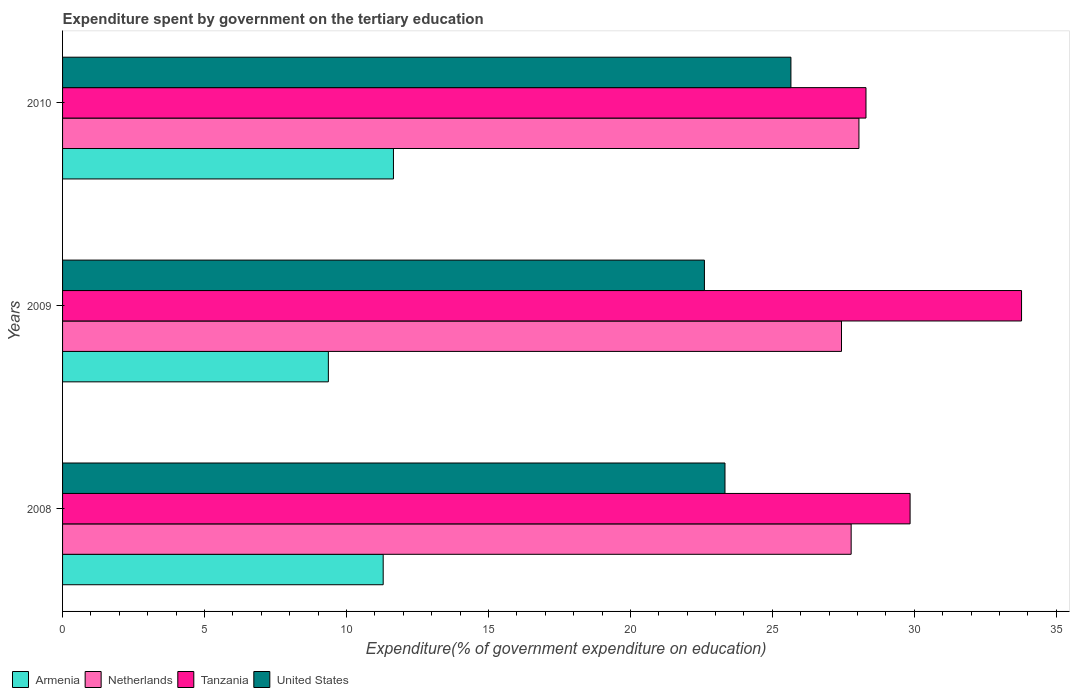How many different coloured bars are there?
Your answer should be compact. 4. How many groups of bars are there?
Your response must be concise. 3. Are the number of bars per tick equal to the number of legend labels?
Provide a succinct answer. Yes. Are the number of bars on each tick of the Y-axis equal?
Provide a succinct answer. Yes. How many bars are there on the 3rd tick from the top?
Your response must be concise. 4. What is the expenditure spent by government on the tertiary education in Netherlands in 2008?
Offer a very short reply. 27.77. Across all years, what is the maximum expenditure spent by government on the tertiary education in Armenia?
Make the answer very short. 11.65. Across all years, what is the minimum expenditure spent by government on the tertiary education in United States?
Provide a succinct answer. 22.61. In which year was the expenditure spent by government on the tertiary education in Netherlands maximum?
Offer a very short reply. 2010. What is the total expenditure spent by government on the tertiary education in Netherlands in the graph?
Ensure brevity in your answer.  83.26. What is the difference between the expenditure spent by government on the tertiary education in Armenia in 2008 and that in 2010?
Offer a terse response. -0.36. What is the difference between the expenditure spent by government on the tertiary education in Armenia in 2010 and the expenditure spent by government on the tertiary education in Tanzania in 2009?
Your response must be concise. -22.12. What is the average expenditure spent by government on the tertiary education in Tanzania per year?
Provide a succinct answer. 30.64. In the year 2009, what is the difference between the expenditure spent by government on the tertiary education in United States and expenditure spent by government on the tertiary education in Netherlands?
Your answer should be compact. -4.83. What is the ratio of the expenditure spent by government on the tertiary education in Netherlands in 2009 to that in 2010?
Give a very brief answer. 0.98. What is the difference between the highest and the second highest expenditure spent by government on the tertiary education in Netherlands?
Make the answer very short. 0.27. What is the difference between the highest and the lowest expenditure spent by government on the tertiary education in Tanzania?
Provide a short and direct response. 5.48. Is the sum of the expenditure spent by government on the tertiary education in United States in 2008 and 2010 greater than the maximum expenditure spent by government on the tertiary education in Armenia across all years?
Your answer should be very brief. Yes. Is it the case that in every year, the sum of the expenditure spent by government on the tertiary education in Tanzania and expenditure spent by government on the tertiary education in Netherlands is greater than the sum of expenditure spent by government on the tertiary education in Armenia and expenditure spent by government on the tertiary education in United States?
Your answer should be compact. Yes. What does the 2nd bar from the top in 2010 represents?
Ensure brevity in your answer.  Tanzania. What does the 3rd bar from the bottom in 2009 represents?
Your answer should be very brief. Tanzania. Is it the case that in every year, the sum of the expenditure spent by government on the tertiary education in Netherlands and expenditure spent by government on the tertiary education in Tanzania is greater than the expenditure spent by government on the tertiary education in United States?
Offer a very short reply. Yes. How many bars are there?
Make the answer very short. 12. Are the values on the major ticks of X-axis written in scientific E-notation?
Offer a terse response. No. Does the graph contain grids?
Make the answer very short. No. Where does the legend appear in the graph?
Offer a terse response. Bottom left. What is the title of the graph?
Provide a short and direct response. Expenditure spent by government on the tertiary education. What is the label or title of the X-axis?
Make the answer very short. Expenditure(% of government expenditure on education). What is the label or title of the Y-axis?
Offer a terse response. Years. What is the Expenditure(% of government expenditure on education) in Armenia in 2008?
Ensure brevity in your answer.  11.29. What is the Expenditure(% of government expenditure on education) in Netherlands in 2008?
Give a very brief answer. 27.77. What is the Expenditure(% of government expenditure on education) of Tanzania in 2008?
Keep it short and to the point. 29.85. What is the Expenditure(% of government expenditure on education) in United States in 2008?
Your answer should be compact. 23.33. What is the Expenditure(% of government expenditure on education) in Armenia in 2009?
Offer a terse response. 9.36. What is the Expenditure(% of government expenditure on education) of Netherlands in 2009?
Offer a terse response. 27.43. What is the Expenditure(% of government expenditure on education) of Tanzania in 2009?
Your answer should be very brief. 33.78. What is the Expenditure(% of government expenditure on education) of United States in 2009?
Your response must be concise. 22.61. What is the Expenditure(% of government expenditure on education) in Armenia in 2010?
Make the answer very short. 11.65. What is the Expenditure(% of government expenditure on education) in Netherlands in 2010?
Your response must be concise. 28.05. What is the Expenditure(% of government expenditure on education) of Tanzania in 2010?
Your answer should be compact. 28.3. What is the Expenditure(% of government expenditure on education) in United States in 2010?
Give a very brief answer. 25.65. Across all years, what is the maximum Expenditure(% of government expenditure on education) of Armenia?
Ensure brevity in your answer.  11.65. Across all years, what is the maximum Expenditure(% of government expenditure on education) in Netherlands?
Provide a succinct answer. 28.05. Across all years, what is the maximum Expenditure(% of government expenditure on education) in Tanzania?
Ensure brevity in your answer.  33.78. Across all years, what is the maximum Expenditure(% of government expenditure on education) of United States?
Give a very brief answer. 25.65. Across all years, what is the minimum Expenditure(% of government expenditure on education) in Armenia?
Ensure brevity in your answer.  9.36. Across all years, what is the minimum Expenditure(% of government expenditure on education) in Netherlands?
Your answer should be very brief. 27.43. Across all years, what is the minimum Expenditure(% of government expenditure on education) in Tanzania?
Your answer should be very brief. 28.3. Across all years, what is the minimum Expenditure(% of government expenditure on education) in United States?
Provide a succinct answer. 22.61. What is the total Expenditure(% of government expenditure on education) in Armenia in the graph?
Your answer should be very brief. 32.31. What is the total Expenditure(% of government expenditure on education) in Netherlands in the graph?
Make the answer very short. 83.26. What is the total Expenditure(% of government expenditure on education) in Tanzania in the graph?
Offer a very short reply. 91.92. What is the total Expenditure(% of government expenditure on education) of United States in the graph?
Make the answer very short. 71.59. What is the difference between the Expenditure(% of government expenditure on education) in Armenia in 2008 and that in 2009?
Offer a terse response. 1.93. What is the difference between the Expenditure(% of government expenditure on education) in Netherlands in 2008 and that in 2009?
Offer a very short reply. 0.34. What is the difference between the Expenditure(% of government expenditure on education) of Tanzania in 2008 and that in 2009?
Make the answer very short. -3.93. What is the difference between the Expenditure(% of government expenditure on education) of United States in 2008 and that in 2009?
Make the answer very short. 0.72. What is the difference between the Expenditure(% of government expenditure on education) of Armenia in 2008 and that in 2010?
Keep it short and to the point. -0.36. What is the difference between the Expenditure(% of government expenditure on education) of Netherlands in 2008 and that in 2010?
Keep it short and to the point. -0.27. What is the difference between the Expenditure(% of government expenditure on education) in Tanzania in 2008 and that in 2010?
Provide a short and direct response. 1.55. What is the difference between the Expenditure(% of government expenditure on education) in United States in 2008 and that in 2010?
Your answer should be compact. -2.32. What is the difference between the Expenditure(% of government expenditure on education) in Armenia in 2009 and that in 2010?
Your response must be concise. -2.29. What is the difference between the Expenditure(% of government expenditure on education) in Netherlands in 2009 and that in 2010?
Your response must be concise. -0.61. What is the difference between the Expenditure(% of government expenditure on education) of Tanzania in 2009 and that in 2010?
Your response must be concise. 5.48. What is the difference between the Expenditure(% of government expenditure on education) in United States in 2009 and that in 2010?
Give a very brief answer. -3.05. What is the difference between the Expenditure(% of government expenditure on education) of Armenia in 2008 and the Expenditure(% of government expenditure on education) of Netherlands in 2009?
Keep it short and to the point. -16.14. What is the difference between the Expenditure(% of government expenditure on education) in Armenia in 2008 and the Expenditure(% of government expenditure on education) in Tanzania in 2009?
Keep it short and to the point. -22.48. What is the difference between the Expenditure(% of government expenditure on education) of Armenia in 2008 and the Expenditure(% of government expenditure on education) of United States in 2009?
Offer a terse response. -11.31. What is the difference between the Expenditure(% of government expenditure on education) in Netherlands in 2008 and the Expenditure(% of government expenditure on education) in Tanzania in 2009?
Make the answer very short. -6. What is the difference between the Expenditure(% of government expenditure on education) in Netherlands in 2008 and the Expenditure(% of government expenditure on education) in United States in 2009?
Your response must be concise. 5.17. What is the difference between the Expenditure(% of government expenditure on education) in Tanzania in 2008 and the Expenditure(% of government expenditure on education) in United States in 2009?
Ensure brevity in your answer.  7.24. What is the difference between the Expenditure(% of government expenditure on education) in Armenia in 2008 and the Expenditure(% of government expenditure on education) in Netherlands in 2010?
Provide a short and direct response. -16.76. What is the difference between the Expenditure(% of government expenditure on education) of Armenia in 2008 and the Expenditure(% of government expenditure on education) of Tanzania in 2010?
Your answer should be very brief. -17. What is the difference between the Expenditure(% of government expenditure on education) of Armenia in 2008 and the Expenditure(% of government expenditure on education) of United States in 2010?
Give a very brief answer. -14.36. What is the difference between the Expenditure(% of government expenditure on education) in Netherlands in 2008 and the Expenditure(% of government expenditure on education) in Tanzania in 2010?
Your answer should be very brief. -0.52. What is the difference between the Expenditure(% of government expenditure on education) in Netherlands in 2008 and the Expenditure(% of government expenditure on education) in United States in 2010?
Provide a short and direct response. 2.12. What is the difference between the Expenditure(% of government expenditure on education) in Tanzania in 2008 and the Expenditure(% of government expenditure on education) in United States in 2010?
Your response must be concise. 4.2. What is the difference between the Expenditure(% of government expenditure on education) in Armenia in 2009 and the Expenditure(% of government expenditure on education) in Netherlands in 2010?
Keep it short and to the point. -18.69. What is the difference between the Expenditure(% of government expenditure on education) of Armenia in 2009 and the Expenditure(% of government expenditure on education) of Tanzania in 2010?
Your answer should be compact. -18.94. What is the difference between the Expenditure(% of government expenditure on education) in Armenia in 2009 and the Expenditure(% of government expenditure on education) in United States in 2010?
Offer a very short reply. -16.29. What is the difference between the Expenditure(% of government expenditure on education) of Netherlands in 2009 and the Expenditure(% of government expenditure on education) of Tanzania in 2010?
Your response must be concise. -0.86. What is the difference between the Expenditure(% of government expenditure on education) of Netherlands in 2009 and the Expenditure(% of government expenditure on education) of United States in 2010?
Offer a very short reply. 1.78. What is the difference between the Expenditure(% of government expenditure on education) of Tanzania in 2009 and the Expenditure(% of government expenditure on education) of United States in 2010?
Ensure brevity in your answer.  8.12. What is the average Expenditure(% of government expenditure on education) in Armenia per year?
Make the answer very short. 10.77. What is the average Expenditure(% of government expenditure on education) of Netherlands per year?
Offer a terse response. 27.75. What is the average Expenditure(% of government expenditure on education) of Tanzania per year?
Your answer should be very brief. 30.64. What is the average Expenditure(% of government expenditure on education) of United States per year?
Your answer should be very brief. 23.86. In the year 2008, what is the difference between the Expenditure(% of government expenditure on education) in Armenia and Expenditure(% of government expenditure on education) in Netherlands?
Keep it short and to the point. -16.48. In the year 2008, what is the difference between the Expenditure(% of government expenditure on education) of Armenia and Expenditure(% of government expenditure on education) of Tanzania?
Offer a very short reply. -18.56. In the year 2008, what is the difference between the Expenditure(% of government expenditure on education) of Armenia and Expenditure(% of government expenditure on education) of United States?
Your response must be concise. -12.04. In the year 2008, what is the difference between the Expenditure(% of government expenditure on education) of Netherlands and Expenditure(% of government expenditure on education) of Tanzania?
Your response must be concise. -2.08. In the year 2008, what is the difference between the Expenditure(% of government expenditure on education) in Netherlands and Expenditure(% of government expenditure on education) in United States?
Your response must be concise. 4.44. In the year 2008, what is the difference between the Expenditure(% of government expenditure on education) of Tanzania and Expenditure(% of government expenditure on education) of United States?
Provide a short and direct response. 6.52. In the year 2009, what is the difference between the Expenditure(% of government expenditure on education) of Armenia and Expenditure(% of government expenditure on education) of Netherlands?
Make the answer very short. -18.07. In the year 2009, what is the difference between the Expenditure(% of government expenditure on education) in Armenia and Expenditure(% of government expenditure on education) in Tanzania?
Your answer should be compact. -24.41. In the year 2009, what is the difference between the Expenditure(% of government expenditure on education) in Armenia and Expenditure(% of government expenditure on education) in United States?
Ensure brevity in your answer.  -13.25. In the year 2009, what is the difference between the Expenditure(% of government expenditure on education) in Netherlands and Expenditure(% of government expenditure on education) in Tanzania?
Your answer should be very brief. -6.34. In the year 2009, what is the difference between the Expenditure(% of government expenditure on education) of Netherlands and Expenditure(% of government expenditure on education) of United States?
Make the answer very short. 4.83. In the year 2009, what is the difference between the Expenditure(% of government expenditure on education) in Tanzania and Expenditure(% of government expenditure on education) in United States?
Your response must be concise. 11.17. In the year 2010, what is the difference between the Expenditure(% of government expenditure on education) of Armenia and Expenditure(% of government expenditure on education) of Netherlands?
Provide a succinct answer. -16.39. In the year 2010, what is the difference between the Expenditure(% of government expenditure on education) in Armenia and Expenditure(% of government expenditure on education) in Tanzania?
Keep it short and to the point. -16.64. In the year 2010, what is the difference between the Expenditure(% of government expenditure on education) in Armenia and Expenditure(% of government expenditure on education) in United States?
Make the answer very short. -14. In the year 2010, what is the difference between the Expenditure(% of government expenditure on education) of Netherlands and Expenditure(% of government expenditure on education) of Tanzania?
Provide a succinct answer. -0.25. In the year 2010, what is the difference between the Expenditure(% of government expenditure on education) in Netherlands and Expenditure(% of government expenditure on education) in United States?
Provide a succinct answer. 2.4. In the year 2010, what is the difference between the Expenditure(% of government expenditure on education) of Tanzania and Expenditure(% of government expenditure on education) of United States?
Your response must be concise. 2.64. What is the ratio of the Expenditure(% of government expenditure on education) of Armenia in 2008 to that in 2009?
Your response must be concise. 1.21. What is the ratio of the Expenditure(% of government expenditure on education) in Netherlands in 2008 to that in 2009?
Make the answer very short. 1.01. What is the ratio of the Expenditure(% of government expenditure on education) of Tanzania in 2008 to that in 2009?
Make the answer very short. 0.88. What is the ratio of the Expenditure(% of government expenditure on education) in United States in 2008 to that in 2009?
Offer a very short reply. 1.03. What is the ratio of the Expenditure(% of government expenditure on education) in Netherlands in 2008 to that in 2010?
Give a very brief answer. 0.99. What is the ratio of the Expenditure(% of government expenditure on education) of Tanzania in 2008 to that in 2010?
Your response must be concise. 1.05. What is the ratio of the Expenditure(% of government expenditure on education) of United States in 2008 to that in 2010?
Ensure brevity in your answer.  0.91. What is the ratio of the Expenditure(% of government expenditure on education) of Armenia in 2009 to that in 2010?
Your answer should be very brief. 0.8. What is the ratio of the Expenditure(% of government expenditure on education) in Netherlands in 2009 to that in 2010?
Your answer should be very brief. 0.98. What is the ratio of the Expenditure(% of government expenditure on education) of Tanzania in 2009 to that in 2010?
Your response must be concise. 1.19. What is the ratio of the Expenditure(% of government expenditure on education) in United States in 2009 to that in 2010?
Your answer should be compact. 0.88. What is the difference between the highest and the second highest Expenditure(% of government expenditure on education) in Armenia?
Make the answer very short. 0.36. What is the difference between the highest and the second highest Expenditure(% of government expenditure on education) in Netherlands?
Give a very brief answer. 0.27. What is the difference between the highest and the second highest Expenditure(% of government expenditure on education) of Tanzania?
Provide a succinct answer. 3.93. What is the difference between the highest and the second highest Expenditure(% of government expenditure on education) of United States?
Your answer should be compact. 2.32. What is the difference between the highest and the lowest Expenditure(% of government expenditure on education) in Armenia?
Offer a very short reply. 2.29. What is the difference between the highest and the lowest Expenditure(% of government expenditure on education) of Netherlands?
Provide a succinct answer. 0.61. What is the difference between the highest and the lowest Expenditure(% of government expenditure on education) in Tanzania?
Make the answer very short. 5.48. What is the difference between the highest and the lowest Expenditure(% of government expenditure on education) of United States?
Offer a very short reply. 3.05. 